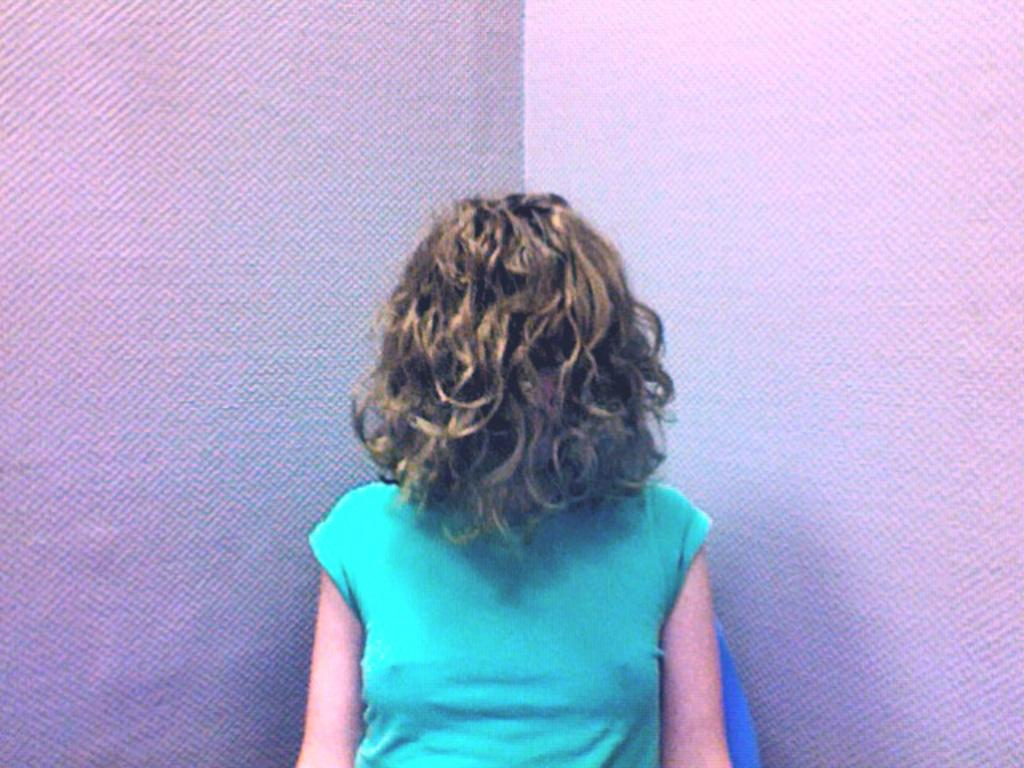Who or what is the main subject in the image? There is a person in the image. What is the person wearing? The person is wearing a green t-shirt. What color is the background of the image? The background of the image is white. Why is the person crying in the image? There is no indication in the image that the person is crying; they are simply wearing a green t-shirt in front of a white background. 